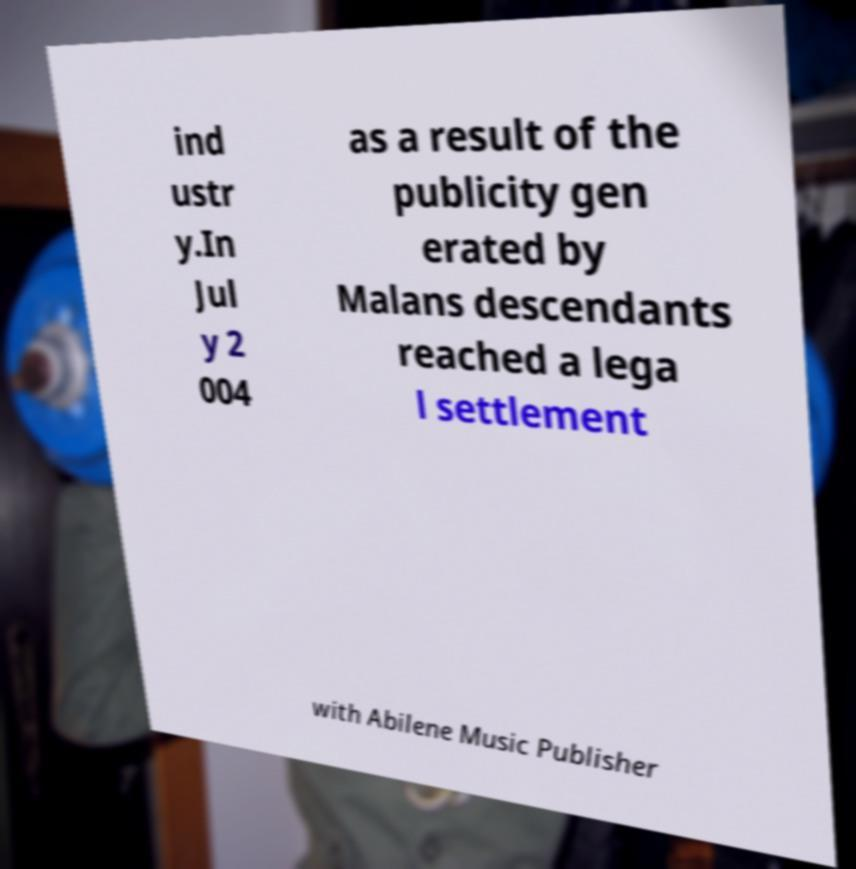Can you read and provide the text displayed in the image?This photo seems to have some interesting text. Can you extract and type it out for me? ind ustr y.In Jul y 2 004 as a result of the publicity gen erated by Malans descendants reached a lega l settlement with Abilene Music Publisher 